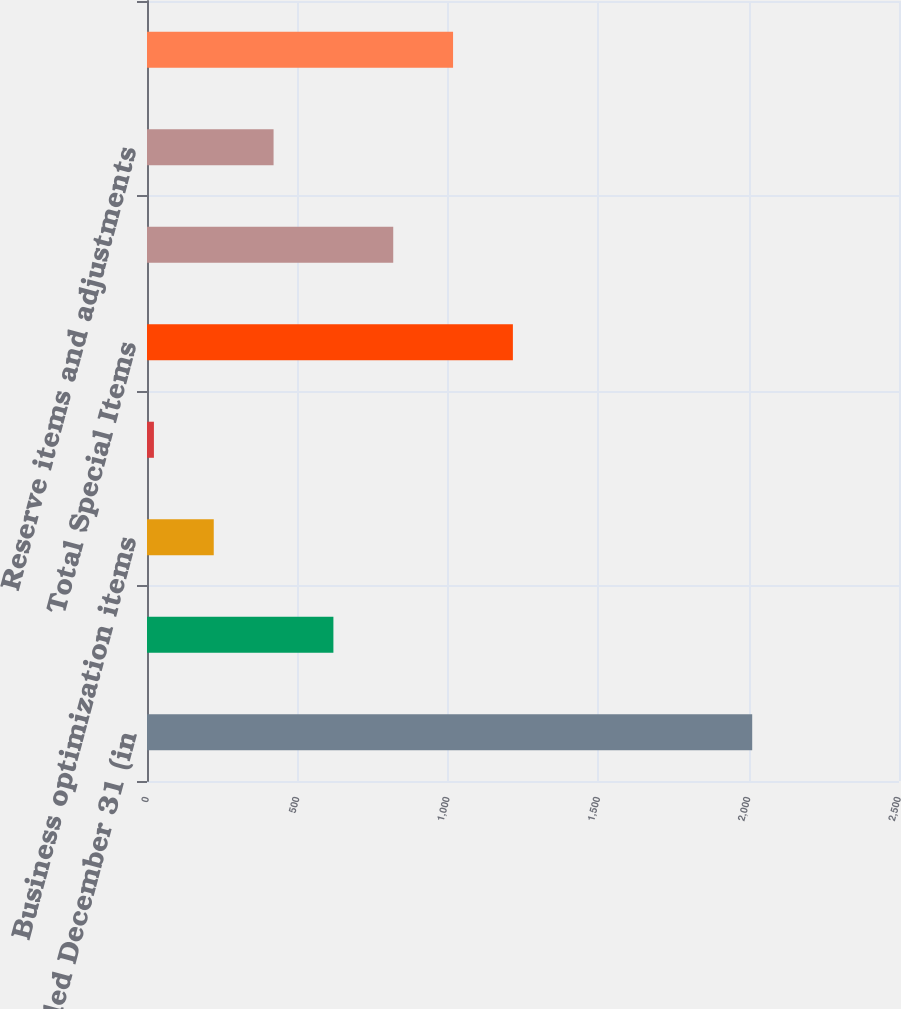<chart> <loc_0><loc_0><loc_500><loc_500><bar_chart><fcel>years ended December 31 (in<fcel>Intangible asset amortization<fcel>Business optimization items<fcel>Product-related items<fcel>Total Special Items<fcel>Business development items<fcel>Reserve items and adjustments<fcel>Impact of special items<nl><fcel>2012<fcel>619.7<fcel>221.9<fcel>23<fcel>1216.4<fcel>818.6<fcel>420.8<fcel>1017.5<nl></chart> 